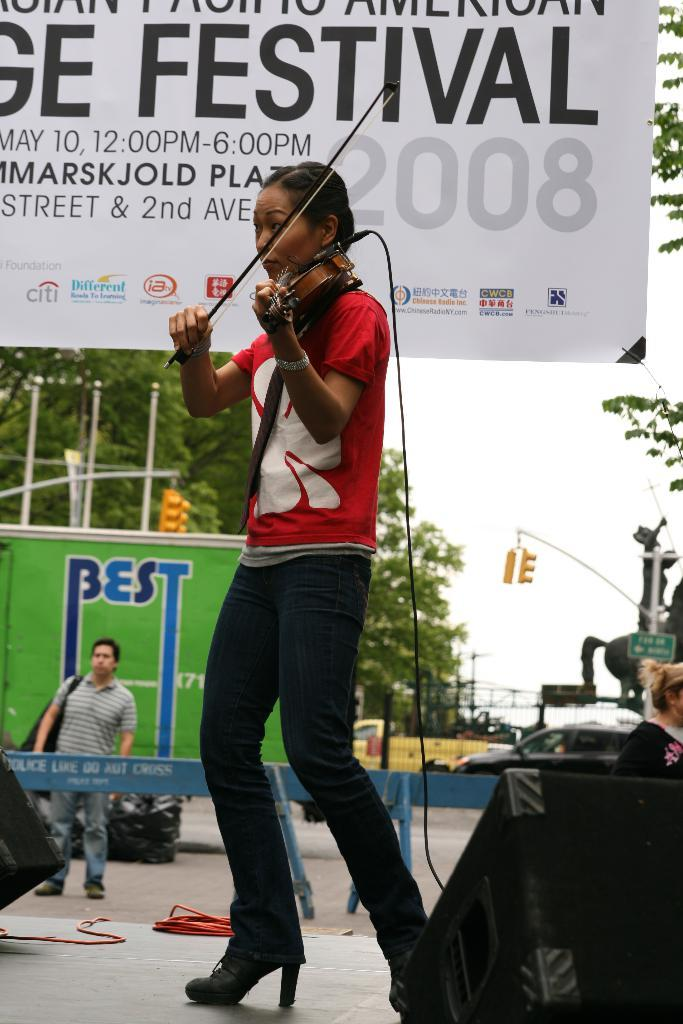What is the woman on the stage doing? The woman on the stage is playing the violin. What can be seen in the background of the image? There is a hoarding and trees in the image. What else is present in the image? There is a vehicle and the sky is visible in the image. Can you see a lawyer holding a tray with a toe on it in the image? No, there is no lawyer, tray, or toe present in the image. 